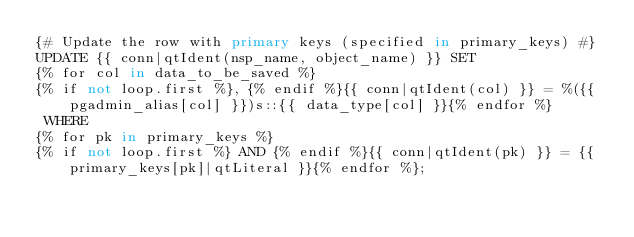Convert code to text. <code><loc_0><loc_0><loc_500><loc_500><_SQL_>{# Update the row with primary keys (specified in primary_keys) #}
UPDATE {{ conn|qtIdent(nsp_name, object_name) }} SET
{% for col in data_to_be_saved %}
{% if not loop.first %}, {% endif %}{{ conn|qtIdent(col) }} = %({{ pgadmin_alias[col] }})s::{{ data_type[col] }}{% endfor %}
 WHERE
{% for pk in primary_keys %}
{% if not loop.first %} AND {% endif %}{{ conn|qtIdent(pk) }} = {{ primary_keys[pk]|qtLiteral }}{% endfor %};
</code> 